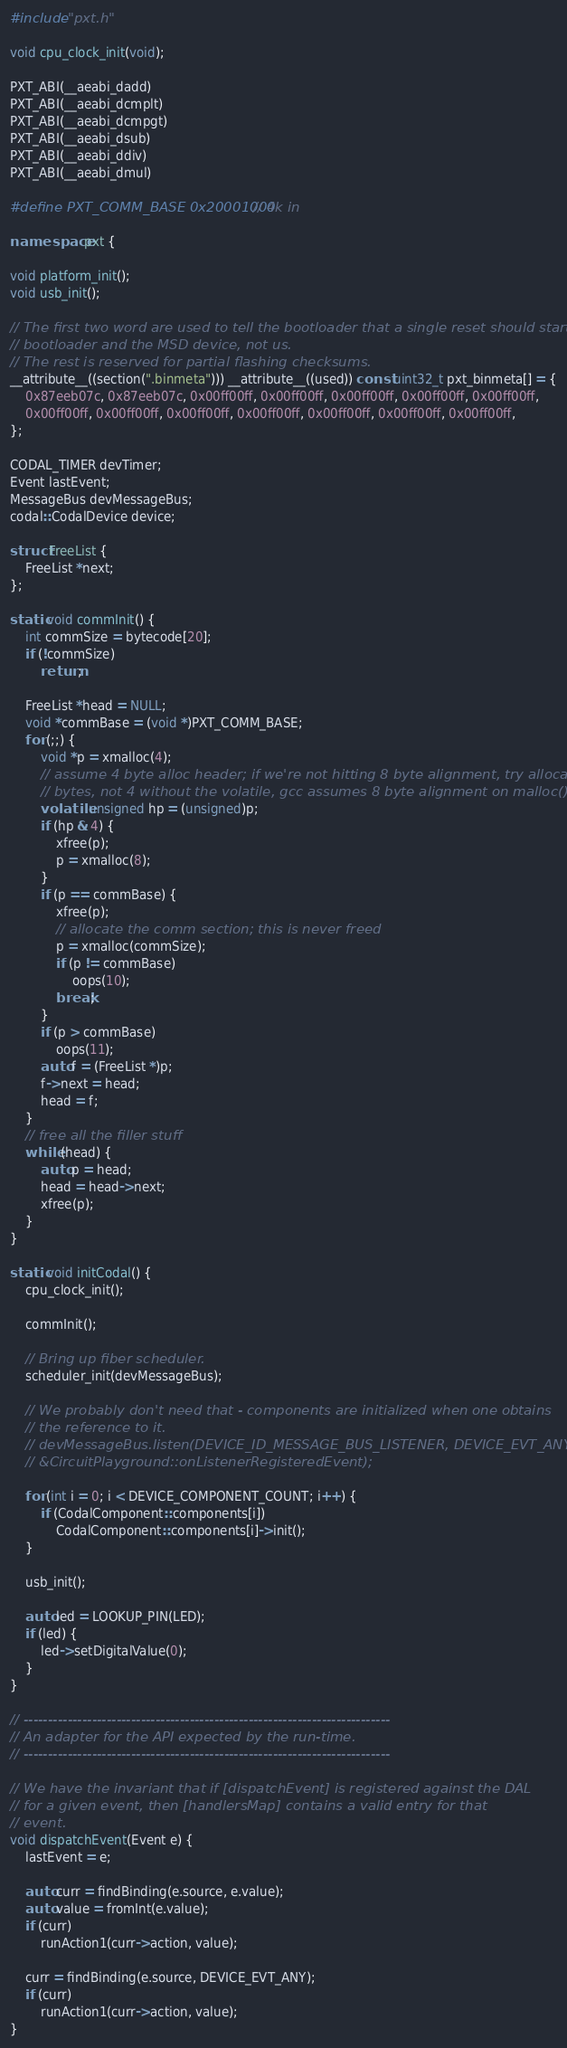<code> <loc_0><loc_0><loc_500><loc_500><_C++_>#include "pxt.h"

void cpu_clock_init(void);

PXT_ABI(__aeabi_dadd)
PXT_ABI(__aeabi_dcmplt)
PXT_ABI(__aeabi_dcmpgt)
PXT_ABI(__aeabi_dsub)
PXT_ABI(__aeabi_ddiv)
PXT_ABI(__aeabi_dmul)

#define PXT_COMM_BASE 0x20001000 // 4k in

namespace pxt {

void platform_init();
void usb_init();

// The first two word are used to tell the bootloader that a single reset should start the
// bootloader and the MSD device, not us.
// The rest is reserved for partial flashing checksums.
__attribute__((section(".binmeta"))) __attribute__((used)) const uint32_t pxt_binmeta[] = {
    0x87eeb07c, 0x87eeb07c, 0x00ff00ff, 0x00ff00ff, 0x00ff00ff, 0x00ff00ff, 0x00ff00ff,
    0x00ff00ff, 0x00ff00ff, 0x00ff00ff, 0x00ff00ff, 0x00ff00ff, 0x00ff00ff, 0x00ff00ff,
};

CODAL_TIMER devTimer;
Event lastEvent;
MessageBus devMessageBus;
codal::CodalDevice device;

struct FreeList {
    FreeList *next;
};

static void commInit() {
    int commSize = bytecode[20];
    if (!commSize)
        return;

    FreeList *head = NULL;
    void *commBase = (void *)PXT_COMM_BASE;
    for (;;) {
        void *p = xmalloc(4);
        // assume 4 byte alloc header; if we're not hitting 8 byte alignment, try allocating 8
        // bytes, not 4 without the volatile, gcc assumes 8 byte alignment on malloc()
        volatile unsigned hp = (unsigned)p;
        if (hp & 4) {
            xfree(p);
            p = xmalloc(8);
        }
        if (p == commBase) {
            xfree(p);
            // allocate the comm section; this is never freed
            p = xmalloc(commSize);
            if (p != commBase)
                oops(10);
            break;
        }
        if (p > commBase)
            oops(11);
        auto f = (FreeList *)p;
        f->next = head;
        head = f;
    }
    // free all the filler stuff
    while (head) {
        auto p = head;
        head = head->next;
        xfree(p);
    }
}

static void initCodal() {
    cpu_clock_init();

    commInit();

    // Bring up fiber scheduler.
    scheduler_init(devMessageBus);

    // We probably don't need that - components are initialized when one obtains
    // the reference to it.
    // devMessageBus.listen(DEVICE_ID_MESSAGE_BUS_LISTENER, DEVICE_EVT_ANY, this,
    // &CircuitPlayground::onListenerRegisteredEvent);

    for (int i = 0; i < DEVICE_COMPONENT_COUNT; i++) {
        if (CodalComponent::components[i])
            CodalComponent::components[i]->init();
    }

    usb_init();

    auto led = LOOKUP_PIN(LED);
    if (led) {
        led->setDigitalValue(0);
    }
}

// ---------------------------------------------------------------------------
// An adapter for the API expected by the run-time.
// ---------------------------------------------------------------------------

// We have the invariant that if [dispatchEvent] is registered against the DAL
// for a given event, then [handlersMap] contains a valid entry for that
// event.
void dispatchEvent(Event e) {
    lastEvent = e;

    auto curr = findBinding(e.source, e.value);
    auto value = fromInt(e.value);
    if (curr)
        runAction1(curr->action, value);

    curr = findBinding(e.source, DEVICE_EVT_ANY);
    if (curr)
        runAction1(curr->action, value);
}
</code> 